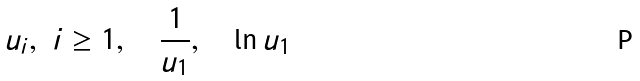Convert formula to latex. <formula><loc_0><loc_0><loc_500><loc_500>u _ { i } , \ i \geq 1 , \quad \frac { 1 } { u _ { 1 } } , \quad \ln u _ { 1 }</formula> 